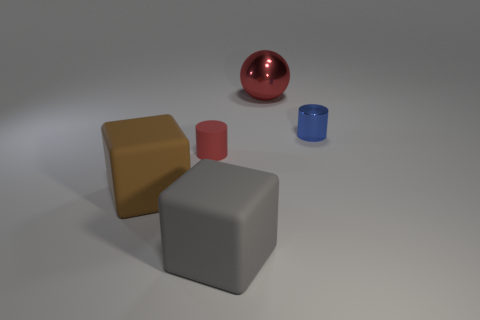How many things are both in front of the blue cylinder and behind the brown thing?
Make the answer very short. 1. Are there more red objects that are in front of the small rubber cylinder than small blue metallic objects that are on the right side of the red sphere?
Your answer should be compact. No. What size is the blue metallic cylinder?
Make the answer very short. Small. Is there a large red object that has the same shape as the large brown object?
Give a very brief answer. No. There is a brown matte object; is it the same shape as the object in front of the brown object?
Provide a succinct answer. Yes. What is the size of the rubber thing that is behind the gray matte cube and in front of the tiny red matte cylinder?
Provide a succinct answer. Large. What number of large blue metal blocks are there?
Your answer should be compact. 0. There is another thing that is the same size as the blue metallic object; what material is it?
Provide a succinct answer. Rubber. Are there any cubes of the same size as the sphere?
Your response must be concise. Yes. There is a big rubber object in front of the large brown matte object; is its color the same as the cylinder on the right side of the large red metal object?
Keep it short and to the point. No. 